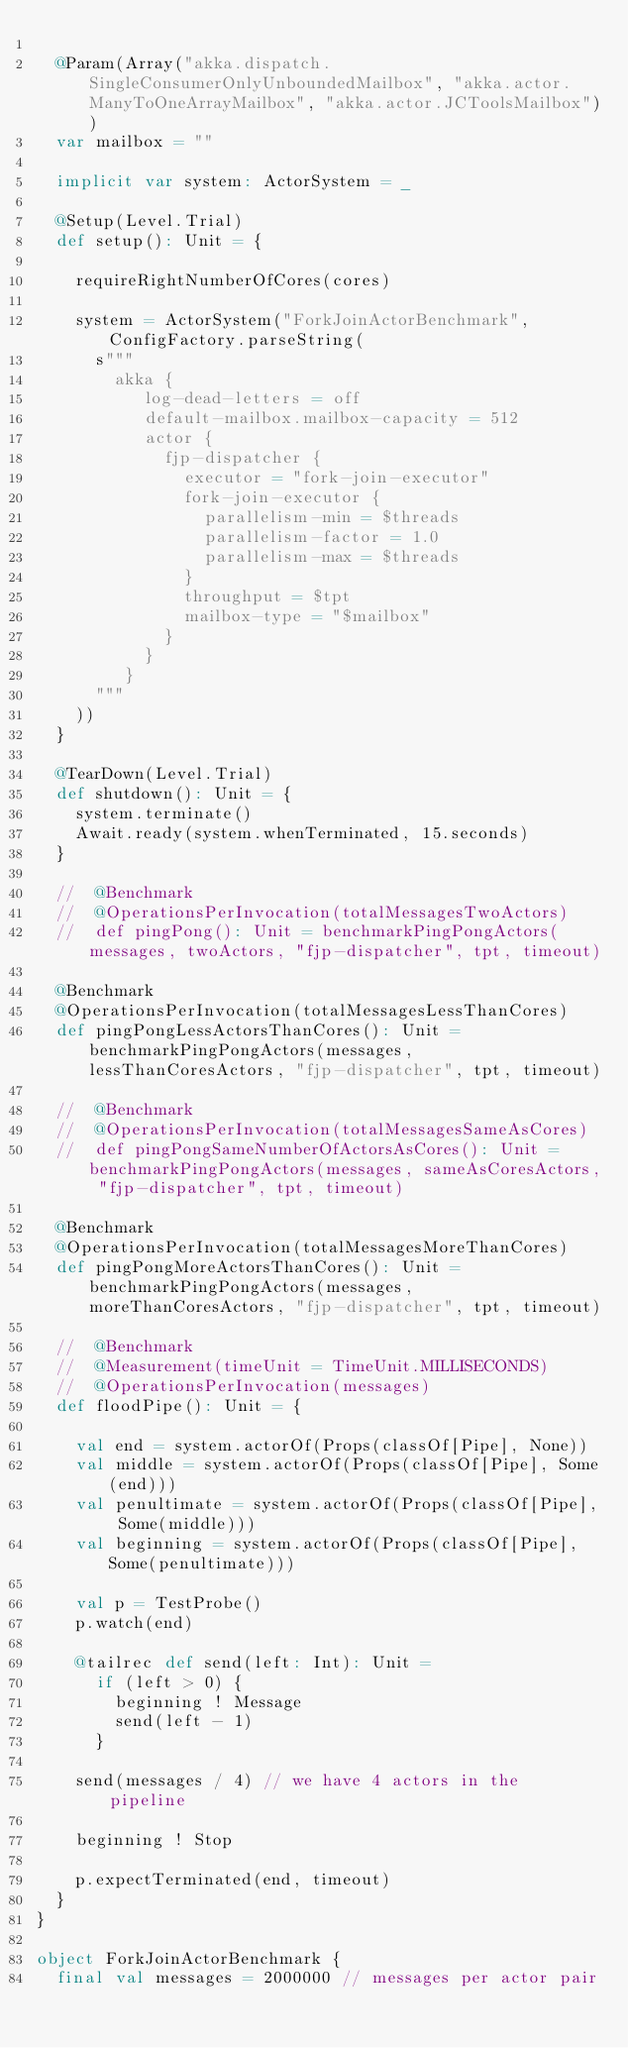<code> <loc_0><loc_0><loc_500><loc_500><_Scala_>
  @Param(Array("akka.dispatch.SingleConsumerOnlyUnboundedMailbox", "akka.actor.ManyToOneArrayMailbox", "akka.actor.JCToolsMailbox"))
  var mailbox = ""

  implicit var system: ActorSystem = _

  @Setup(Level.Trial)
  def setup(): Unit = {

    requireRightNumberOfCores(cores)

    system = ActorSystem("ForkJoinActorBenchmark", ConfigFactory.parseString(
      s"""
        akka {
           log-dead-letters = off
           default-mailbox.mailbox-capacity = 512
           actor {
             fjp-dispatcher {
               executor = "fork-join-executor"
               fork-join-executor {
                 parallelism-min = $threads
                 parallelism-factor = 1.0
                 parallelism-max = $threads
               }
               throughput = $tpt
               mailbox-type = "$mailbox"
             }
           }
         }
      """
    ))
  }

  @TearDown(Level.Trial)
  def shutdown(): Unit = {
    system.terminate()
    Await.ready(system.whenTerminated, 15.seconds)
  }

  //  @Benchmark
  //  @OperationsPerInvocation(totalMessagesTwoActors)
  //  def pingPong(): Unit = benchmarkPingPongActors(messages, twoActors, "fjp-dispatcher", tpt, timeout)

  @Benchmark
  @OperationsPerInvocation(totalMessagesLessThanCores)
  def pingPongLessActorsThanCores(): Unit = benchmarkPingPongActors(messages, lessThanCoresActors, "fjp-dispatcher", tpt, timeout)

  //  @Benchmark
  //  @OperationsPerInvocation(totalMessagesSameAsCores)
  //  def pingPongSameNumberOfActorsAsCores(): Unit = benchmarkPingPongActors(messages, sameAsCoresActors, "fjp-dispatcher", tpt, timeout)

  @Benchmark
  @OperationsPerInvocation(totalMessagesMoreThanCores)
  def pingPongMoreActorsThanCores(): Unit = benchmarkPingPongActors(messages, moreThanCoresActors, "fjp-dispatcher", tpt, timeout)

  //  @Benchmark
  //  @Measurement(timeUnit = TimeUnit.MILLISECONDS)
  //  @OperationsPerInvocation(messages)
  def floodPipe(): Unit = {

    val end = system.actorOf(Props(classOf[Pipe], None))
    val middle = system.actorOf(Props(classOf[Pipe], Some(end)))
    val penultimate = system.actorOf(Props(classOf[Pipe], Some(middle)))
    val beginning = system.actorOf(Props(classOf[Pipe], Some(penultimate)))

    val p = TestProbe()
    p.watch(end)

    @tailrec def send(left: Int): Unit =
      if (left > 0) {
        beginning ! Message
        send(left - 1)
      }

    send(messages / 4) // we have 4 actors in the pipeline

    beginning ! Stop

    p.expectTerminated(end, timeout)
  }
}

object ForkJoinActorBenchmark {
  final val messages = 2000000 // messages per actor pair
</code> 